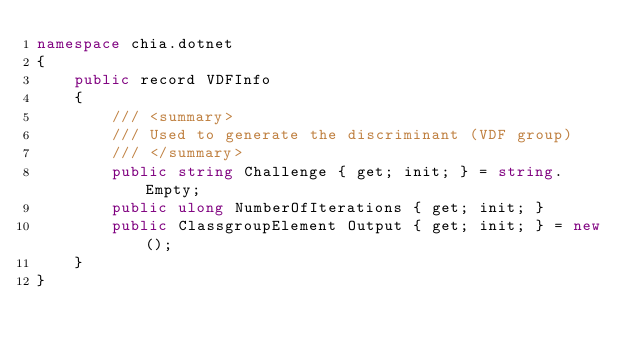Convert code to text. <code><loc_0><loc_0><loc_500><loc_500><_C#_>namespace chia.dotnet
{
    public record VDFInfo
    {
        /// <summary>
        /// Used to generate the discriminant (VDF group)
        /// </summary>
        public string Challenge { get; init; } = string.Empty;
        public ulong NumberOfIterations { get; init; }
        public ClassgroupElement Output { get; init; } = new();
    }
}
</code> 